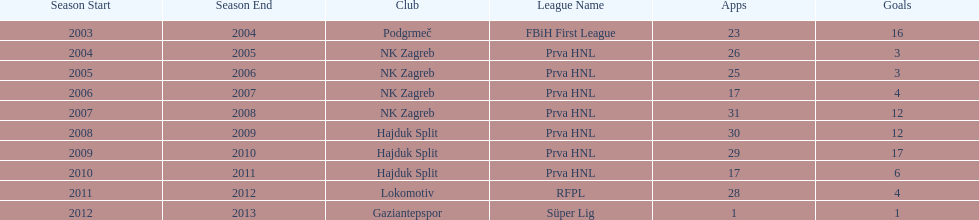At most 26 apps, how many goals were scored in 2004-2005 3. 